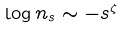Convert formula to latex. <formula><loc_0><loc_0><loc_500><loc_500>\log n _ { s } \sim - s ^ { \zeta }</formula> 